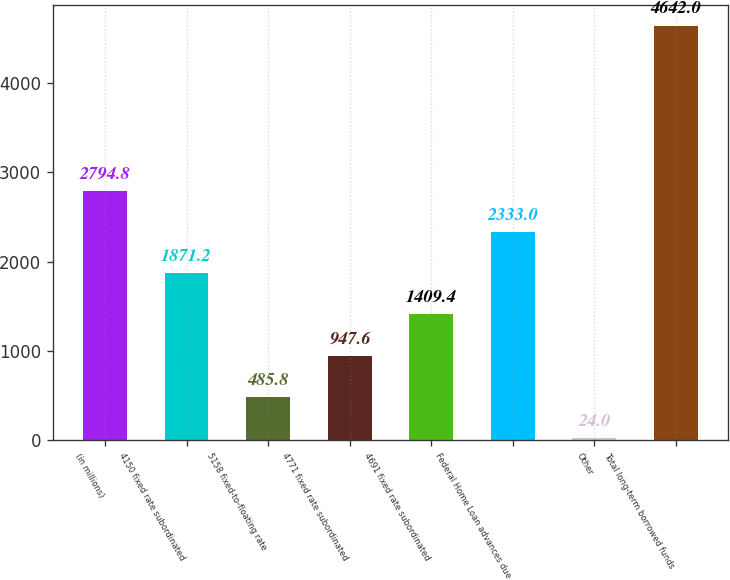Convert chart. <chart><loc_0><loc_0><loc_500><loc_500><bar_chart><fcel>(in millions)<fcel>4150 fixed rate subordinated<fcel>5158 fixed-to-floating rate<fcel>4771 fixed rate subordinated<fcel>4691 fixed rate subordinated<fcel>Federal Home Loan advances due<fcel>Other<fcel>Total long-term borrowed funds<nl><fcel>2794.8<fcel>1871.2<fcel>485.8<fcel>947.6<fcel>1409.4<fcel>2333<fcel>24<fcel>4642<nl></chart> 